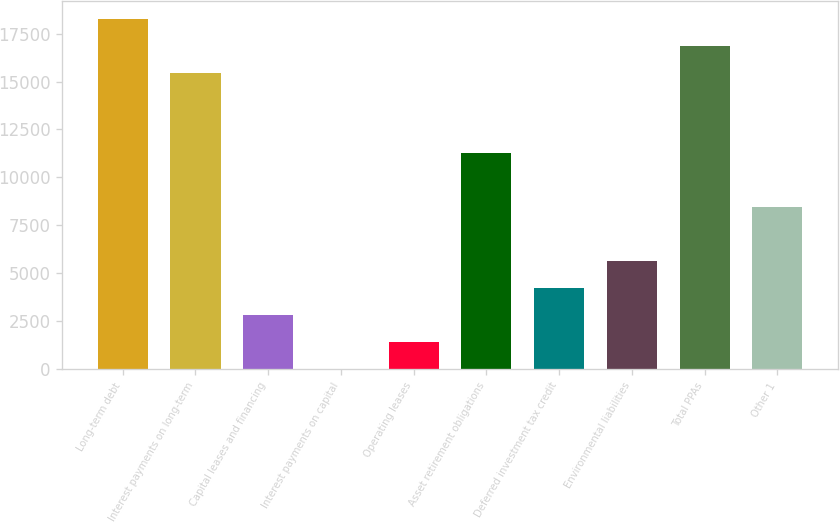<chart> <loc_0><loc_0><loc_500><loc_500><bar_chart><fcel>Long-term debt<fcel>Interest payments on long-term<fcel>Capital leases and financing<fcel>Interest payments on capital<fcel>Operating leases<fcel>Asset retirement obligations<fcel>Deferred investment tax credit<fcel>Environmental liabilities<fcel>Total PPAs<fcel>Other 1<nl><fcel>18281.4<fcel>15469.8<fcel>2817.6<fcel>6<fcel>1411.8<fcel>11252.4<fcel>4223.4<fcel>5629.2<fcel>16875.6<fcel>8440.8<nl></chart> 